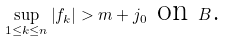Convert formula to latex. <formula><loc_0><loc_0><loc_500><loc_500>\sup _ { 1 \leq k \leq n } \left | f _ { k } \right | > m + j _ { 0 } \text { on } B \text {.}</formula> 